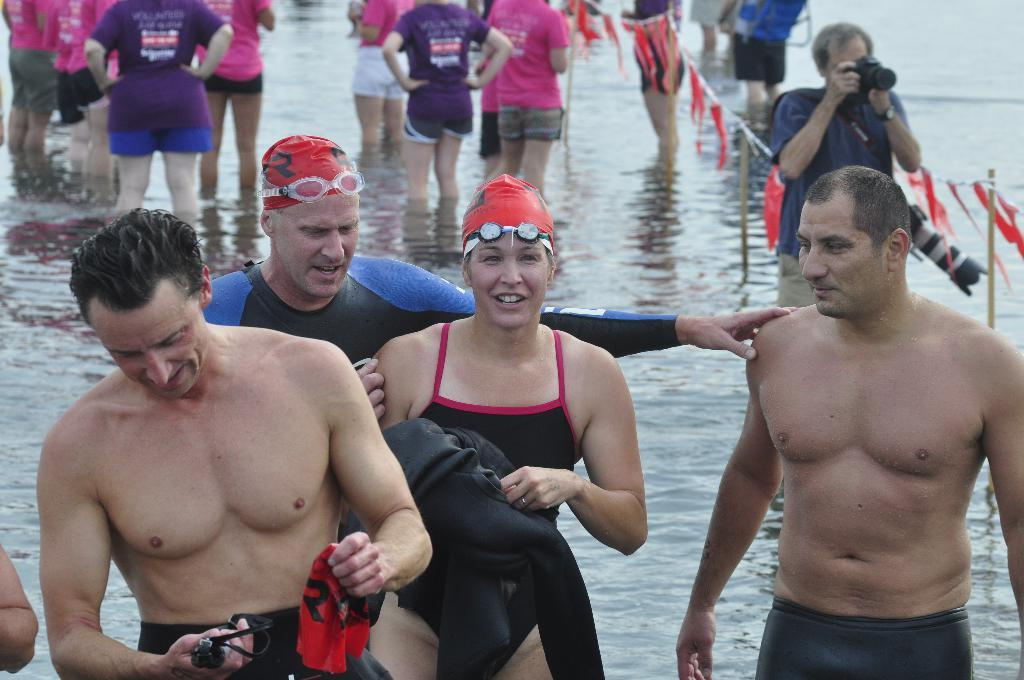What is the main subject of the image? The main subject of the image is a crowd. Where is the crowd located? The crowd is in the water. What other object can be seen in the image? There is a fence in the image. Can you make an educated guess about the location of the image based on the facts? The image may have been taken at a lake, given the presence of water and a crowd. What type of coal is being used to fuel the library in the image? There is no library or coal present in the image. Who is the creator of the crowd in the image? The image is a photograph or illustration, not a creation by a specific individual. The crowd is a natural gathering of people, not an artistic creation. 